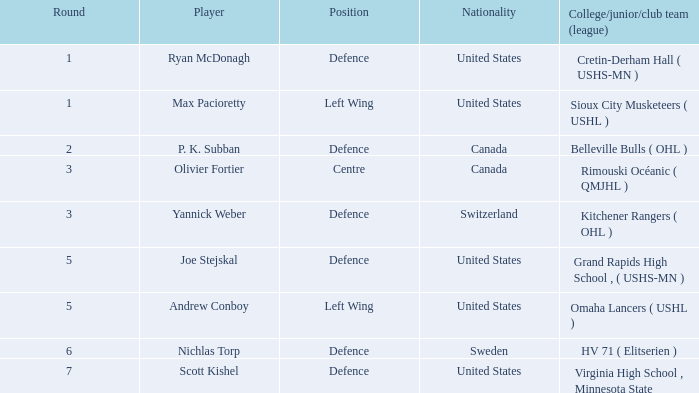Which united states competitor plays defence and was drafted earlier than round 5? Ryan McDonagh. 